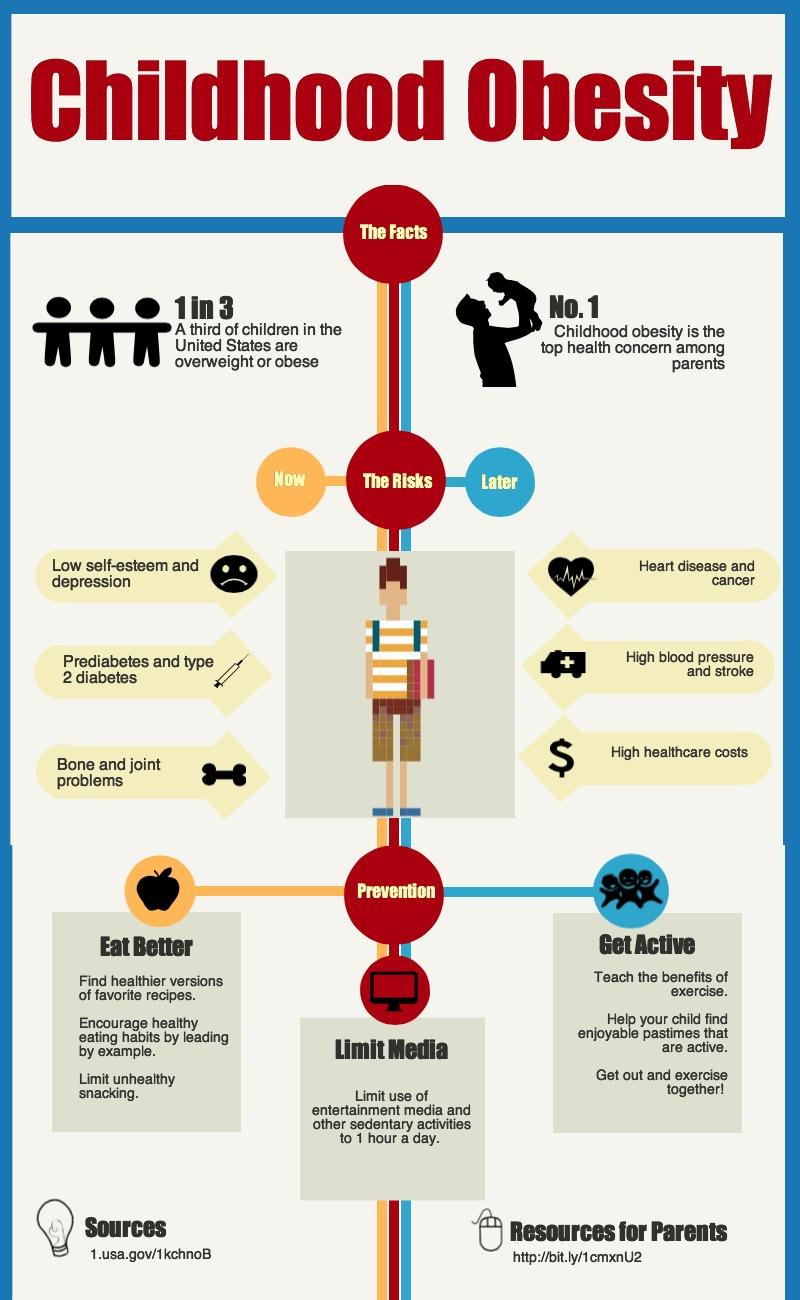List a handful of essential elements in this visual. To prevent childhood obesity, it is essential to adopt a healthy diet, limit screen time, and engage in regular physical activity. 